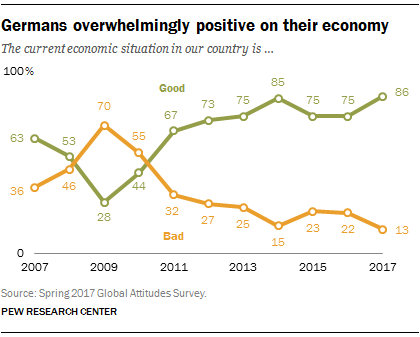Outline some significant characteristics in this image. The sum of the lowest green graph value and the highest orange graph value is 98. The peak value of the orange graph is estimated to be 70. 